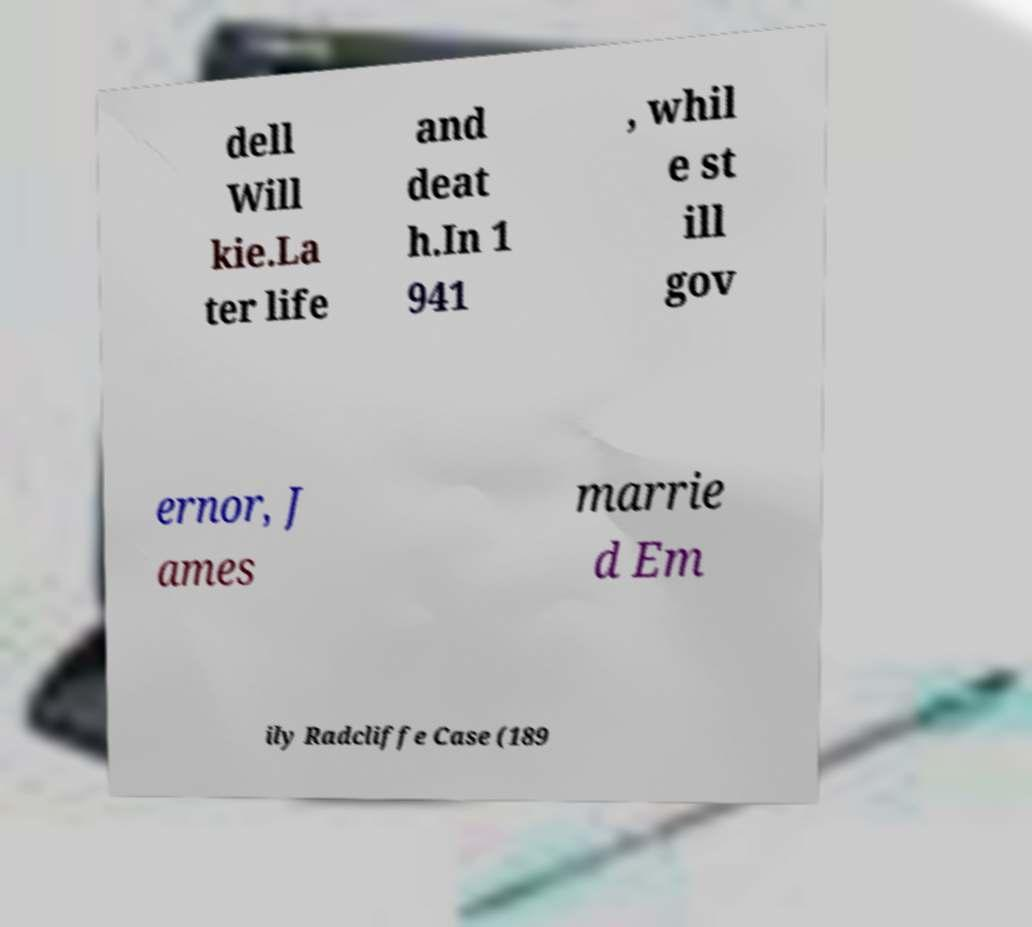Can you read and provide the text displayed in the image?This photo seems to have some interesting text. Can you extract and type it out for me? dell Will kie.La ter life and deat h.In 1 941 , whil e st ill gov ernor, J ames marrie d Em ily Radcliffe Case (189 